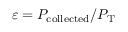Convert formula to latex. <formula><loc_0><loc_0><loc_500><loc_500>\varepsilon = P _ { c o l l e c t e d } / P _ { T }</formula> 